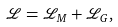Convert formula to latex. <formula><loc_0><loc_0><loc_500><loc_500>\mathcal { L } = \mathcal { L } _ { M } + \mathcal { L } _ { G } ,</formula> 